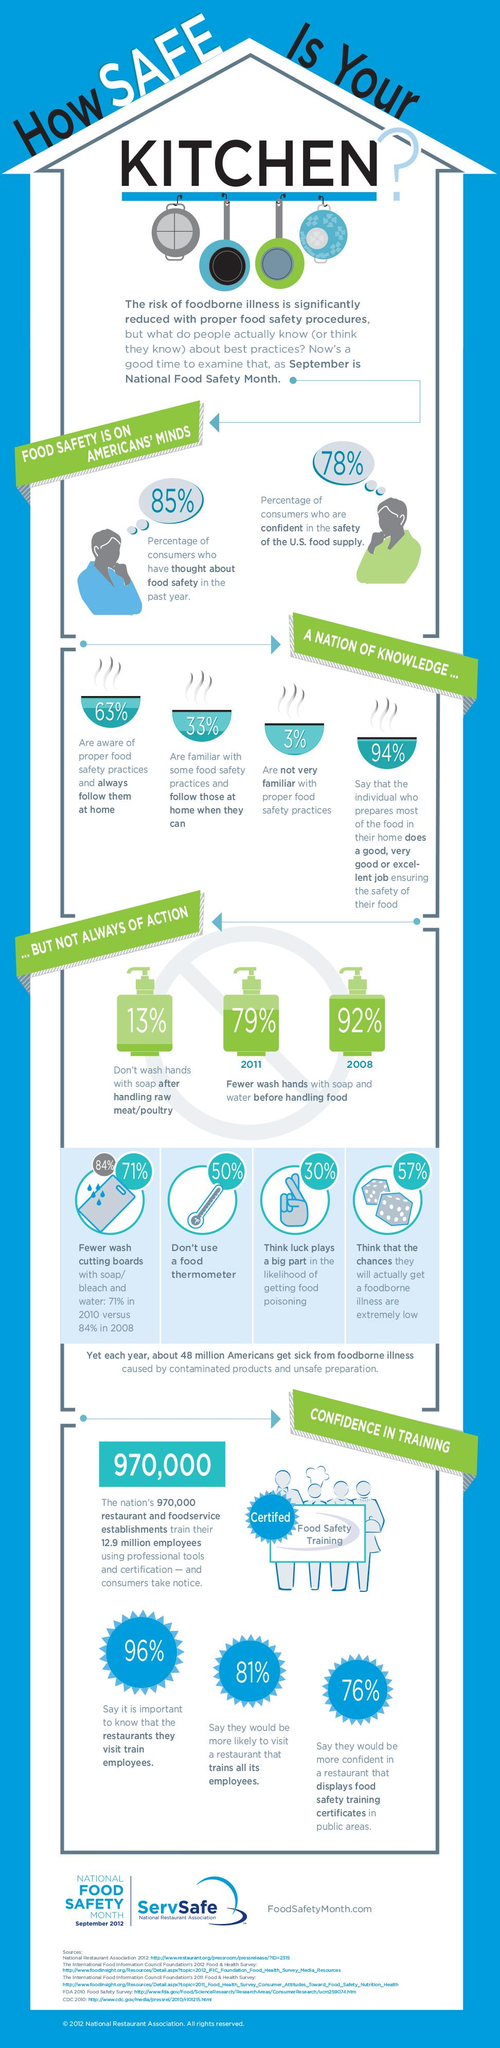Outline some significant characteristics in this image. According to a recent survey, 57% of Americans believe that the chance of getting a food borne illness is extremely low. According to a recent survey, 87% of Americans wash their hands with soap after handling raw or poultry, demonstrating a strong awareness and commitment to food safety practices. According to a survey, 50% of Americans do not use a food thermometer. According to a survey conducted in 2008, 92% of Americans reported practicing only a few hand washes before handling food. According to a recent survey, an overwhelming 97% of Americans are familiar with proper food safety practices. 